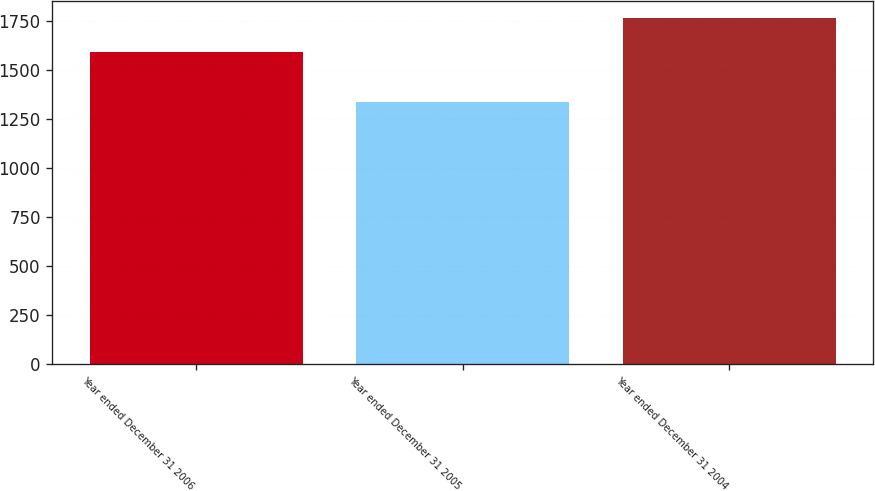Convert chart to OTSL. <chart><loc_0><loc_0><loc_500><loc_500><bar_chart><fcel>Year ended December 31 2006<fcel>Year ended December 31 2005<fcel>Year ended December 31 2004<nl><fcel>1591<fcel>1334<fcel>1765<nl></chart> 